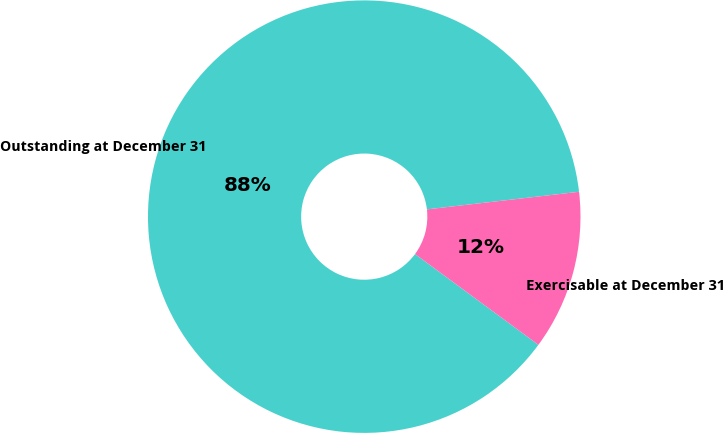Convert chart. <chart><loc_0><loc_0><loc_500><loc_500><pie_chart><fcel>Outstanding at December 31<fcel>Exercisable at December 31<nl><fcel>88.07%<fcel>11.93%<nl></chart> 